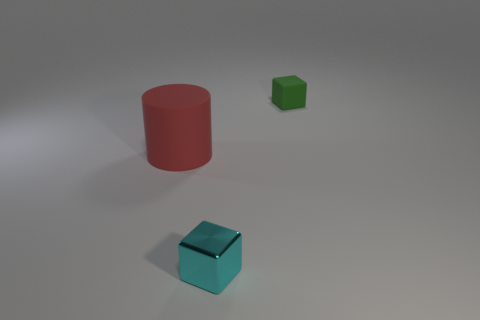Add 3 cyan metallic objects. How many objects exist? 6 Subtract all blocks. How many objects are left? 1 Subtract all brown shiny things. Subtract all tiny objects. How many objects are left? 1 Add 3 metallic things. How many metallic things are left? 4 Add 3 tiny rubber blocks. How many tiny rubber blocks exist? 4 Subtract 0 cyan spheres. How many objects are left? 3 